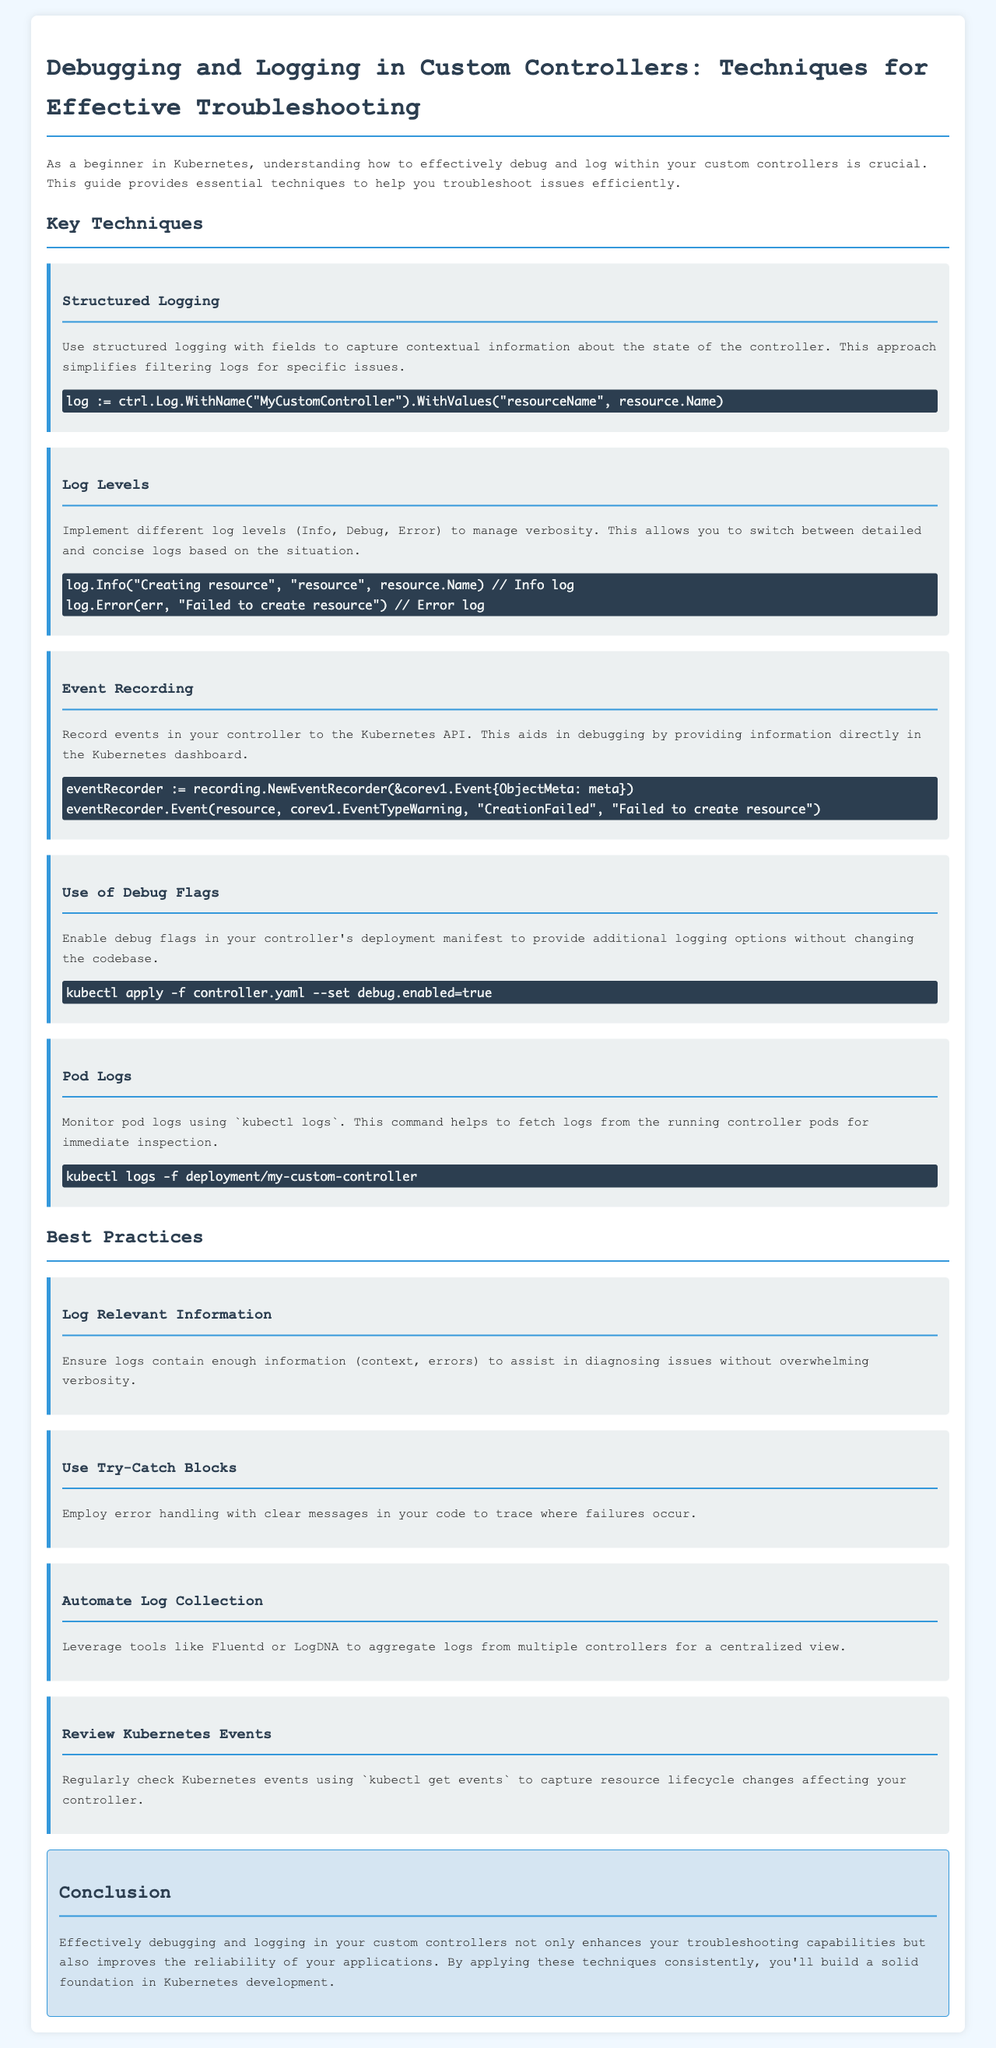What is the title of the document? The title is presented at the very top of the document, clearly indicating the subject it covers.
Answer: Debugging and Logging in Custom Controllers: Techniques for Effective Troubleshooting How many key techniques are listed in the document? The document outlines several techniques under the section titled "Key Techniques."
Answer: Five What is one example of structured logging provided? The document specifies examples of structured logging in the section dedicated to it.
Answer: log := ctrl.Log.WithName("MyCustomController").WithValues("resourceName", resource.Name) Which log level is used for error logs? The document describes the log levels and provides examples related to them.
Answer: Error What tool can be used for automating log collection? The document suggests tools that can help with log aggregation to provide a centralized view of logs.
Answer: Fluentd What Kubernetes command is mentioned for monitoring pod logs? The command provided in the document allows for real-time inspection of logs from running controller pods.
Answer: kubectl logs -f deployment/my-custom-controller Name one best practice related to logging. The document lists best practices under the section titled "Best Practices."
Answer: Log Relevant Information What is the purpose of event recording in custom controllers? The document explains the benefits of recording events to provide insights about resource states directly in the Kubernetes dashboard.
Answer: Aids in debugging How can you enable debug flags in a controller’s deployment? The document provides a specific command to apply debug flags, enhancing logging options.
Answer: kubectl apply -f controller.yaml --set debug.enabled=true 